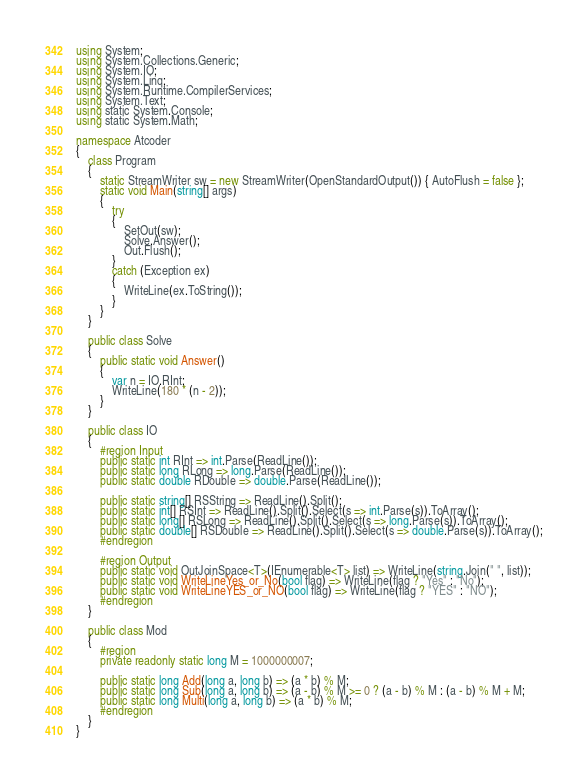<code> <loc_0><loc_0><loc_500><loc_500><_C#_>using System;
using System.Collections.Generic;
using System.IO;
using System.Linq;
using System.Runtime.CompilerServices;
using System.Text;
using static System.Console;
using static System.Math;

namespace Atcoder
{
    class Program
    {
        static StreamWriter sw = new StreamWriter(OpenStandardOutput()) { AutoFlush = false };
        static void Main(string[] args)
        {
            try
            {
                SetOut(sw);
                Solve.Answer();
                Out.Flush();
            }
            catch (Exception ex)
            {
                WriteLine(ex.ToString());
            }
        }
    }

    public class Solve
    {
        public static void Answer()
        {
            var n = IO.RInt;
            WriteLine(180 * (n - 2));
        }
    }

    public class IO
    {
        #region Input
        public static int RInt => int.Parse(ReadLine());
        public static long RLong => long.Parse(ReadLine());
        public static double RDouble => double.Parse(ReadLine());

        public static string[] RSString => ReadLine().Split();
        public static int[] RSInt => ReadLine().Split().Select(s => int.Parse(s)).ToArray();
        public static long[] RSLong => ReadLine().Split().Select(s => long.Parse(s)).ToArray();
        public static double[] RSDouble => ReadLine().Split().Select(s => double.Parse(s)).ToArray();
        #endregion

        #region Output
        public static void OutJoinSpace<T>(IEnumerable<T> list) => WriteLine(string.Join(" ", list));
        public static void WriteLineYes_or_No(bool flag) => WriteLine(flag ? "Yes" : "No");
        public static void WriteLineYES_or_NO(bool flag) => WriteLine(flag ? "YES" : "NO");
        #endregion
    }

    public class Mod
    {
        #region
        private readonly static long M = 1000000007;

        public static long Add(long a, long b) => (a * b) % M;
        public static long Sub(long a, long b) => (a - b) % M >= 0 ? (a - b) % M : (a - b) % M + M;
        public static long Multi(long a, long b) => (a * b) % M;
        #endregion
    }
}</code> 